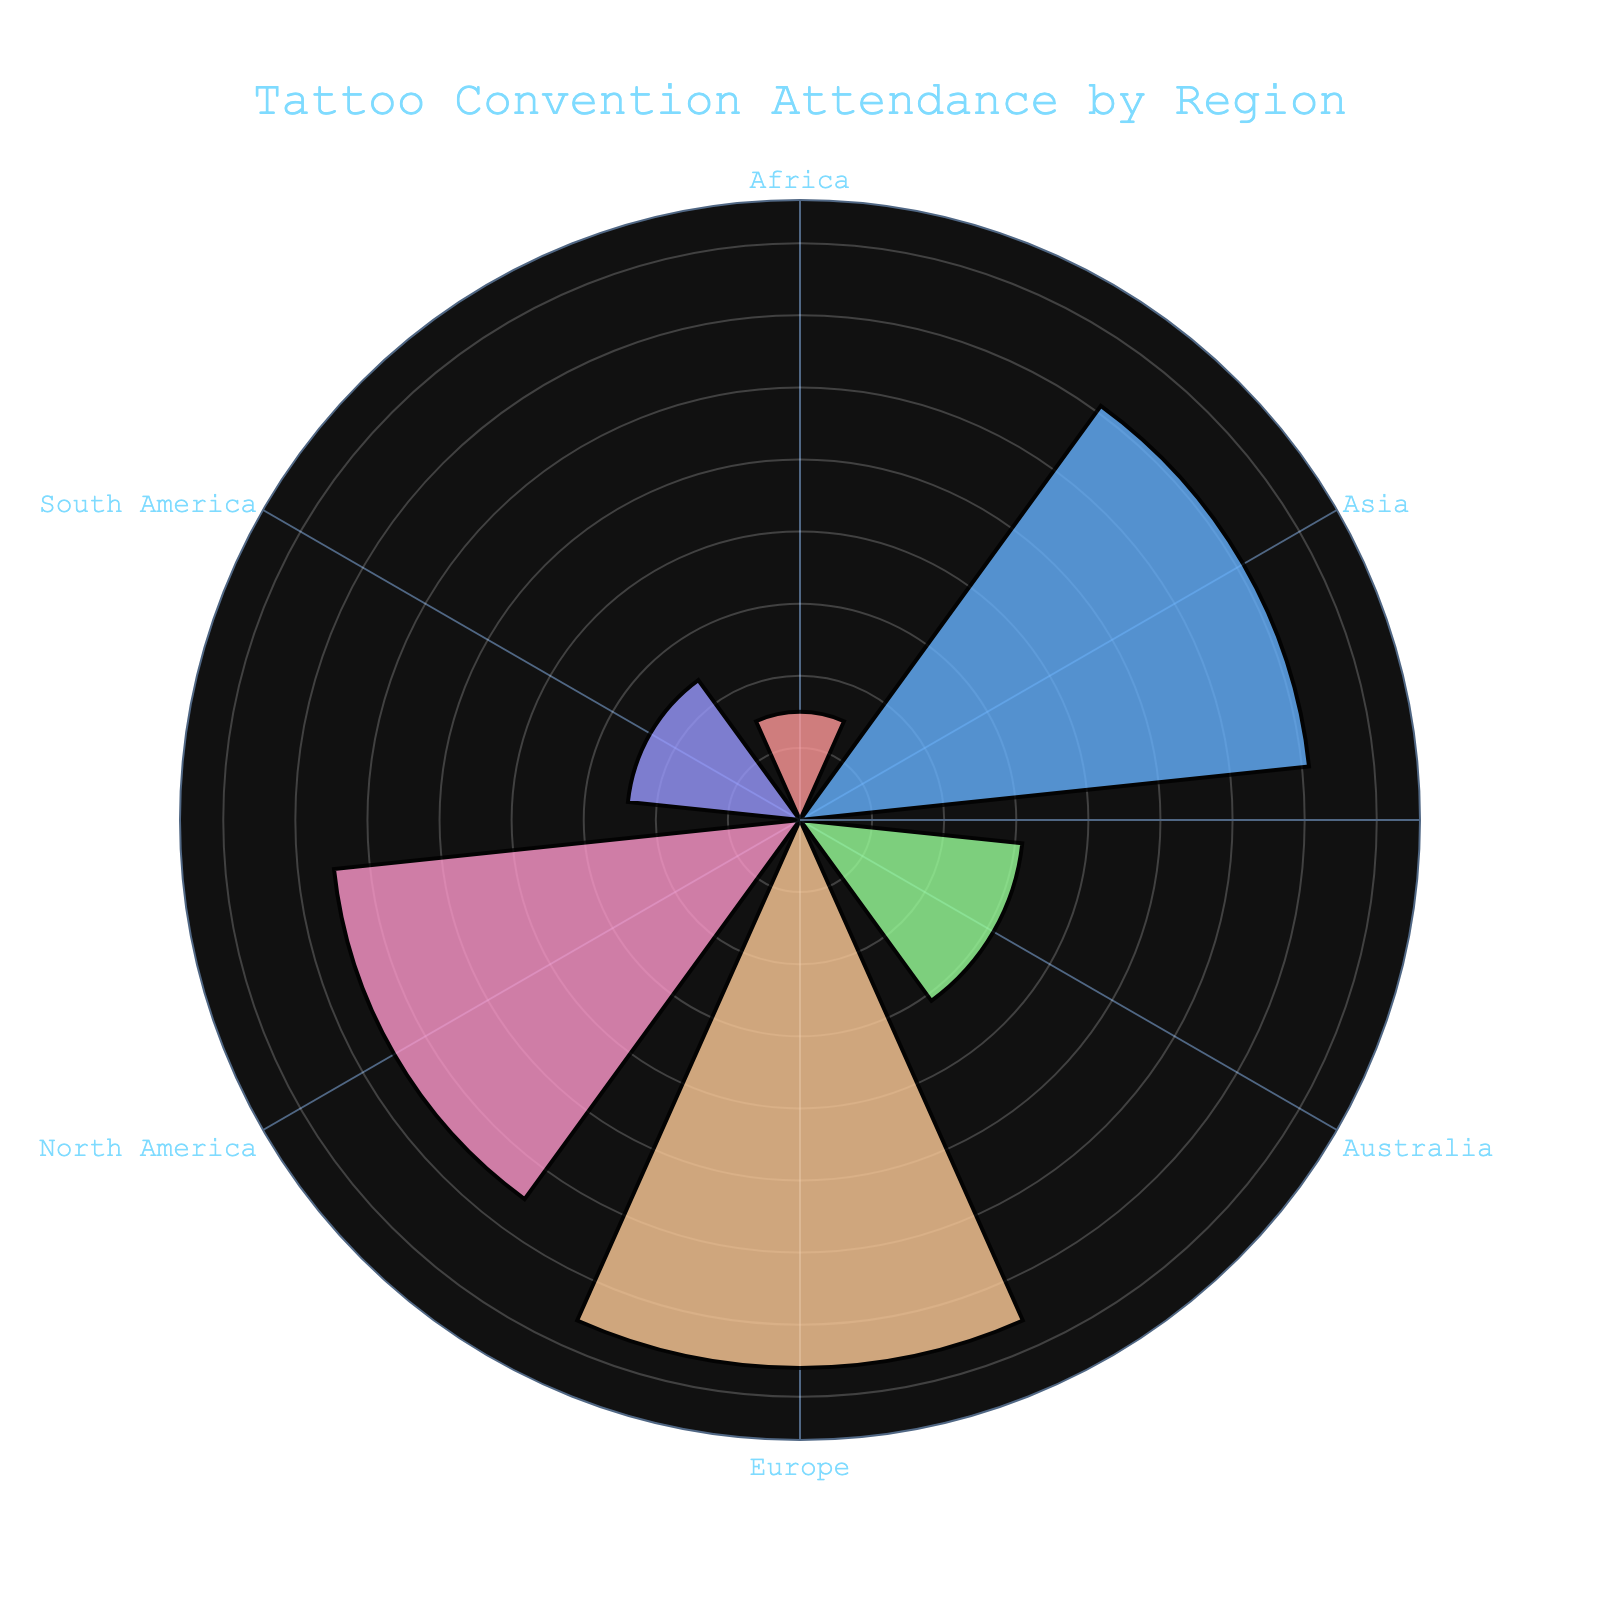What is the highest Attendance Frequency represented in the rose chart and from which region? By looking at the length of the petals and the annotations, the highest Attendance Frequency is from Europe with a frequency of 76.
Answer: Europe (76) Which region has the lowest Attendance Frequency? The smallest petal in the rose chart represents the lowest Attendance Frequency, which is Africa with a frequency of 15.
Answer: Africa (15) What is the sum of Attendance Frequencies for North America and Asia? To find this, we add the Attendance Frequencies for North America (65) and Asia (71). 65 + 71 = 136
Answer: 136 How does the Attendance Frequency of South America compare to that of Australia? By comparing the petal lengths, South America (24) has a lower Attendance Frequency than Australia (31).
Answer: South America is lower What is the average Attendance Frequency across all regions? Summing all the Attendance Frequencies (65 + 76 + 71 + 31 + 24 + 15 = 282) and dividing by the number of regions (6) gives 282 / 6 = 47.
Answer: 47 Which regions have an Attendance Frequency greater than 50? By examining the petals, only Europe (76) and Asia (71) have Attendance Frequencies greater than 50.
Answer: Europe and Asia What is the Attendance Frequency difference between the region with the highest and lowest Attendance Frequencies? Subtracting the lowest Attendance Frequency (Africa, 15) from the highest (Europe, 76) gives 76 - 15 = 61.
Answer: 61 What is the second highest Attendance Frequency and from which region? The second largest petal length indicates that Asia has the second highest Attendance Frequency of 71.
Answer: Asia (71) How many regions have an Attendance Frequency less than 30? By counting the petals with Attendance Frequencies less than 30, we find North America (65), Europe (76), and Asia (71) are excluded. The remaining regions are South America (24), Australia (31), and Africa (15). Excluding Australia (31) leaves South America and Africa.
Answer: 2 